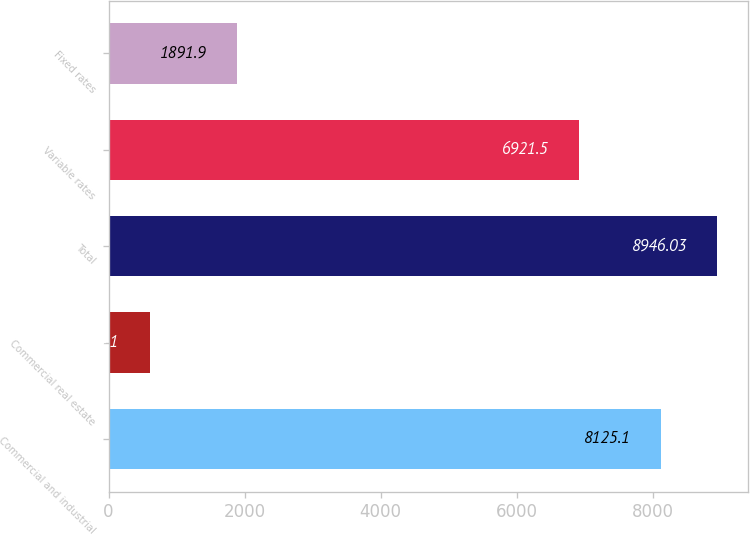Convert chart. <chart><loc_0><loc_0><loc_500><loc_500><bar_chart><fcel>Commercial and industrial<fcel>Commercial real estate<fcel>Total<fcel>Variable rates<fcel>Fixed rates<nl><fcel>8125.1<fcel>604.1<fcel>8946.03<fcel>6921.5<fcel>1891.9<nl></chart> 